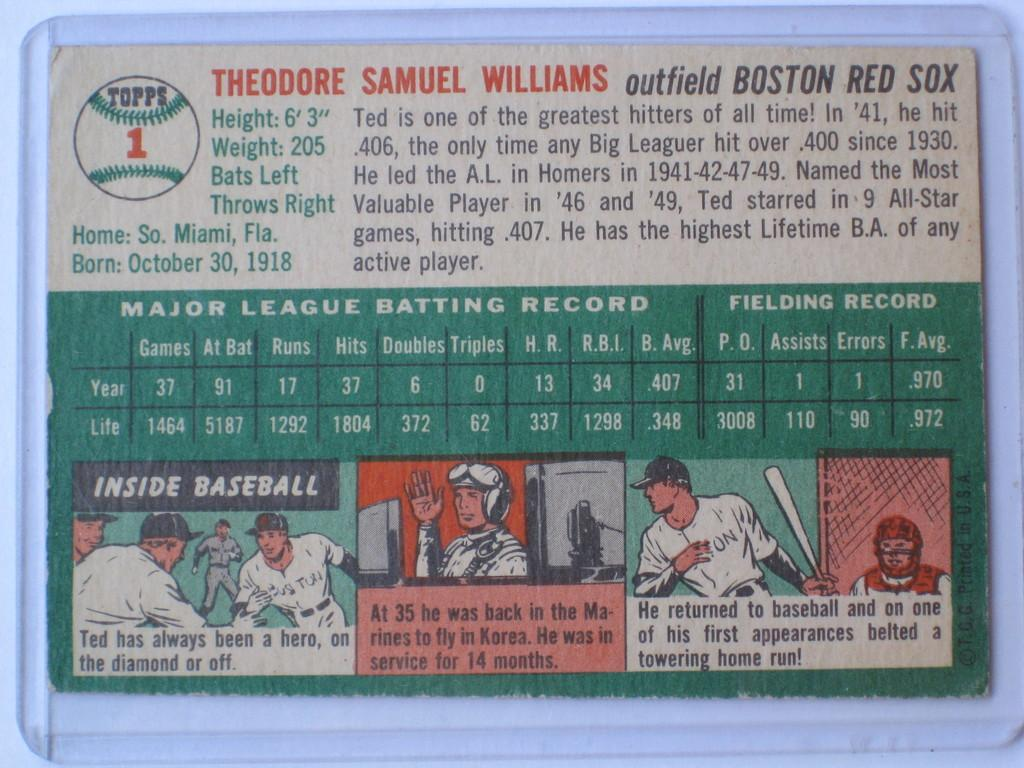What is the main object in the image? There is a board in the image. Where is the board located? The board is attached to a wall. What can be found on the board? There is text and images of persons on the board. How many giants are depicted on the board in the image? There are no giants depicted on the board; it features text and images of persons. What type of wool is used to create the images on the board? There is no wool present in the image, as the images are not made of wool. 